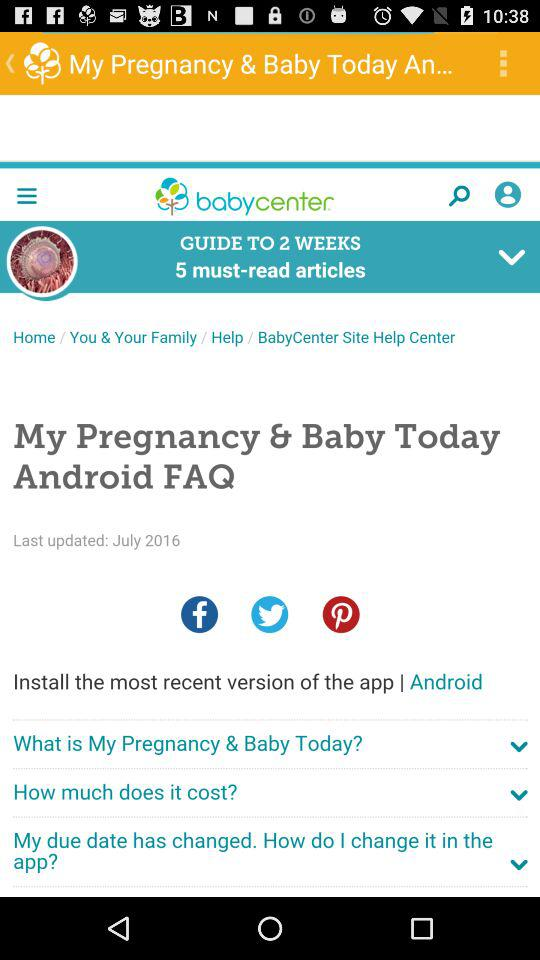Which articles are the 5 must-reads for week 2?
When the provided information is insufficient, respond with <no answer>. <no answer> 